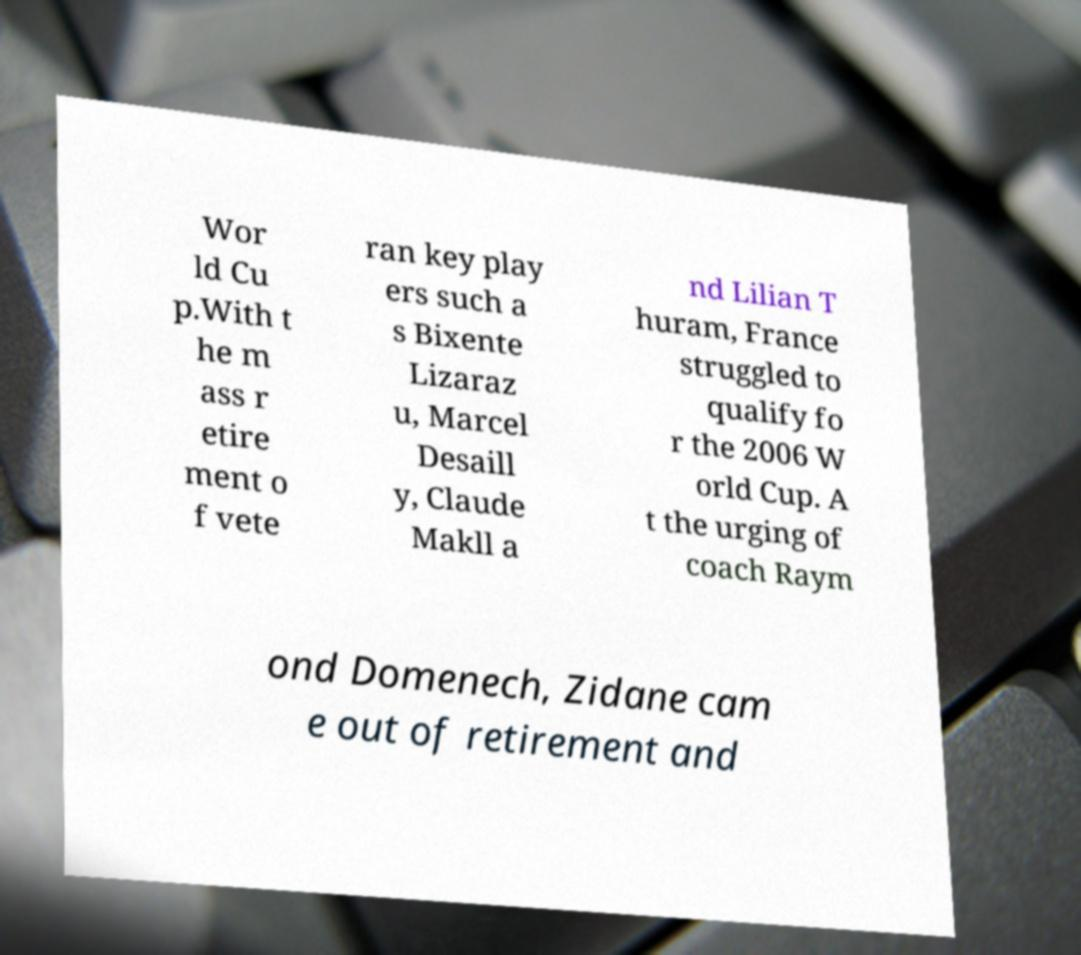Can you read and provide the text displayed in the image?This photo seems to have some interesting text. Can you extract and type it out for me? Wor ld Cu p.With t he m ass r etire ment o f vete ran key play ers such a s Bixente Lizaraz u, Marcel Desaill y, Claude Makll a nd Lilian T huram, France struggled to qualify fo r the 2006 W orld Cup. A t the urging of coach Raym ond Domenech, Zidane cam e out of retirement and 